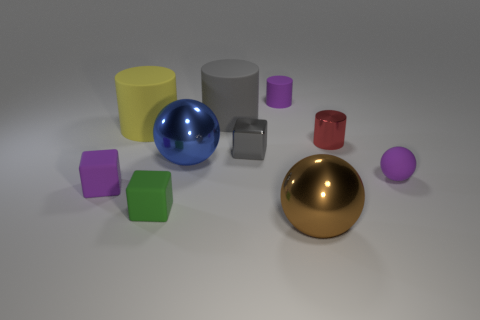How many large things are to the left of the large brown metal object and right of the tiny green block?
Your response must be concise. 2. Is the size of the purple cylinder the same as the purple matte thing that is in front of the purple rubber sphere?
Offer a terse response. Yes. There is a small purple matte object that is in front of the small purple rubber object right of the red cylinder; is there a big brown shiny ball behind it?
Provide a succinct answer. No. What material is the tiny purple object that is on the left side of the purple rubber thing behind the matte ball?
Keep it short and to the point. Rubber. There is a small object that is to the right of the small metallic cube and in front of the small red metal cylinder; what material is it?
Offer a terse response. Rubber. Are there any large cyan matte objects that have the same shape as the big brown thing?
Give a very brief answer. No. Is there a small matte cylinder that is behind the big metallic ball on the left side of the brown object?
Provide a short and direct response. Yes. How many big red balls have the same material as the gray cylinder?
Your answer should be compact. 0. Is there a big red thing?
Ensure brevity in your answer.  No. What number of tiny matte cylinders are the same color as the matte ball?
Your answer should be very brief. 1. 